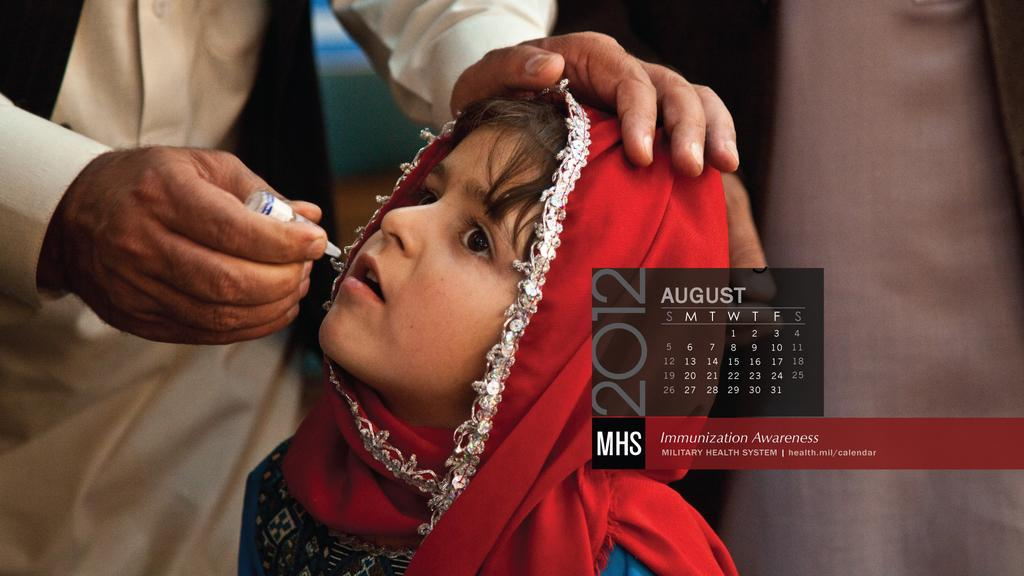What is happening in the image involving people? There are people standing in the image. What object is being held by one of the people? A person is holding a vaccine bottle. What type of item can be seen in the image that is used for tracking dates? There is a calendar in the image. What can be found in the image that contains written information? There is text present in the image. Can you tell me how many pets are visible in the image? There are no pets present in the image. What type of market is shown in the image? There is no market present in the image. 